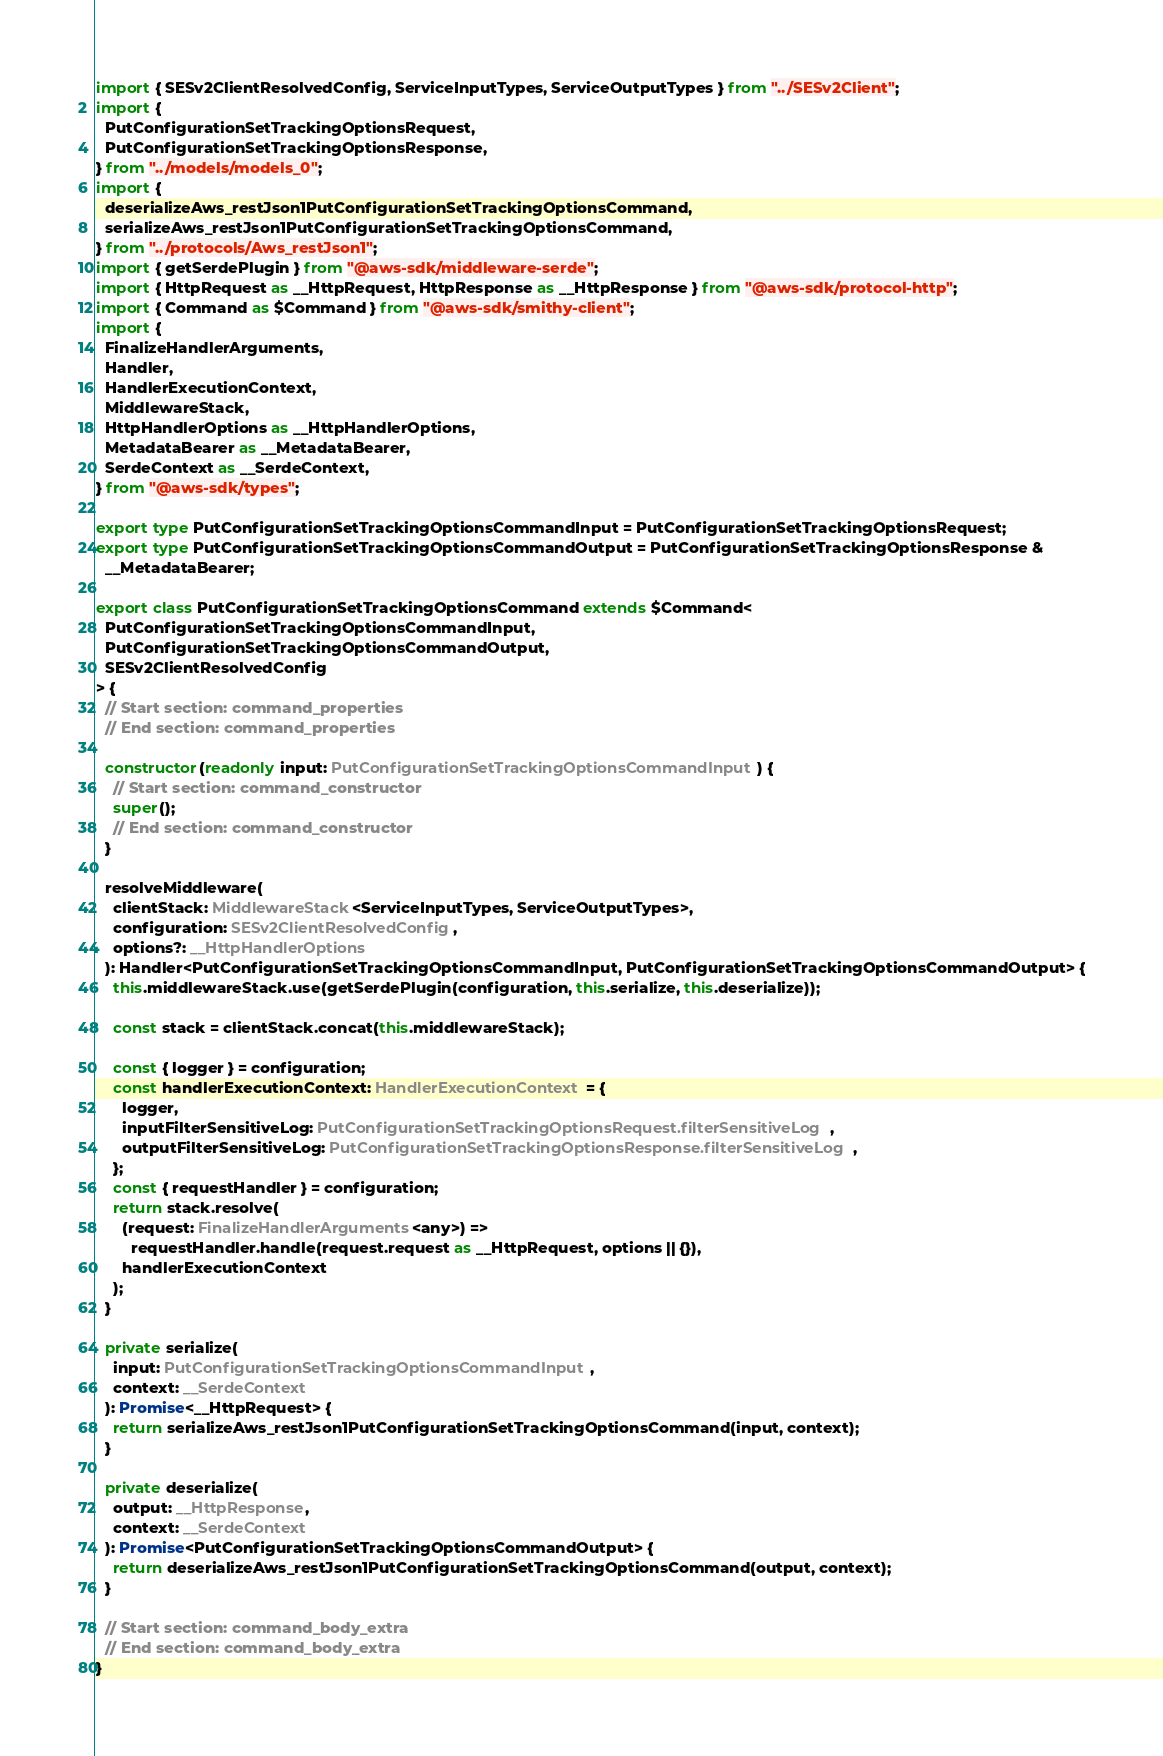<code> <loc_0><loc_0><loc_500><loc_500><_TypeScript_>import { SESv2ClientResolvedConfig, ServiceInputTypes, ServiceOutputTypes } from "../SESv2Client";
import {
  PutConfigurationSetTrackingOptionsRequest,
  PutConfigurationSetTrackingOptionsResponse,
} from "../models/models_0";
import {
  deserializeAws_restJson1PutConfigurationSetTrackingOptionsCommand,
  serializeAws_restJson1PutConfigurationSetTrackingOptionsCommand,
} from "../protocols/Aws_restJson1";
import { getSerdePlugin } from "@aws-sdk/middleware-serde";
import { HttpRequest as __HttpRequest, HttpResponse as __HttpResponse } from "@aws-sdk/protocol-http";
import { Command as $Command } from "@aws-sdk/smithy-client";
import {
  FinalizeHandlerArguments,
  Handler,
  HandlerExecutionContext,
  MiddlewareStack,
  HttpHandlerOptions as __HttpHandlerOptions,
  MetadataBearer as __MetadataBearer,
  SerdeContext as __SerdeContext,
} from "@aws-sdk/types";

export type PutConfigurationSetTrackingOptionsCommandInput = PutConfigurationSetTrackingOptionsRequest;
export type PutConfigurationSetTrackingOptionsCommandOutput = PutConfigurationSetTrackingOptionsResponse &
  __MetadataBearer;

export class PutConfigurationSetTrackingOptionsCommand extends $Command<
  PutConfigurationSetTrackingOptionsCommandInput,
  PutConfigurationSetTrackingOptionsCommandOutput,
  SESv2ClientResolvedConfig
> {
  // Start section: command_properties
  // End section: command_properties

  constructor(readonly input: PutConfigurationSetTrackingOptionsCommandInput) {
    // Start section: command_constructor
    super();
    // End section: command_constructor
  }

  resolveMiddleware(
    clientStack: MiddlewareStack<ServiceInputTypes, ServiceOutputTypes>,
    configuration: SESv2ClientResolvedConfig,
    options?: __HttpHandlerOptions
  ): Handler<PutConfigurationSetTrackingOptionsCommandInput, PutConfigurationSetTrackingOptionsCommandOutput> {
    this.middlewareStack.use(getSerdePlugin(configuration, this.serialize, this.deserialize));

    const stack = clientStack.concat(this.middlewareStack);

    const { logger } = configuration;
    const handlerExecutionContext: HandlerExecutionContext = {
      logger,
      inputFilterSensitiveLog: PutConfigurationSetTrackingOptionsRequest.filterSensitiveLog,
      outputFilterSensitiveLog: PutConfigurationSetTrackingOptionsResponse.filterSensitiveLog,
    };
    const { requestHandler } = configuration;
    return stack.resolve(
      (request: FinalizeHandlerArguments<any>) =>
        requestHandler.handle(request.request as __HttpRequest, options || {}),
      handlerExecutionContext
    );
  }

  private serialize(
    input: PutConfigurationSetTrackingOptionsCommandInput,
    context: __SerdeContext
  ): Promise<__HttpRequest> {
    return serializeAws_restJson1PutConfigurationSetTrackingOptionsCommand(input, context);
  }

  private deserialize(
    output: __HttpResponse,
    context: __SerdeContext
  ): Promise<PutConfigurationSetTrackingOptionsCommandOutput> {
    return deserializeAws_restJson1PutConfigurationSetTrackingOptionsCommand(output, context);
  }

  // Start section: command_body_extra
  // End section: command_body_extra
}
</code> 